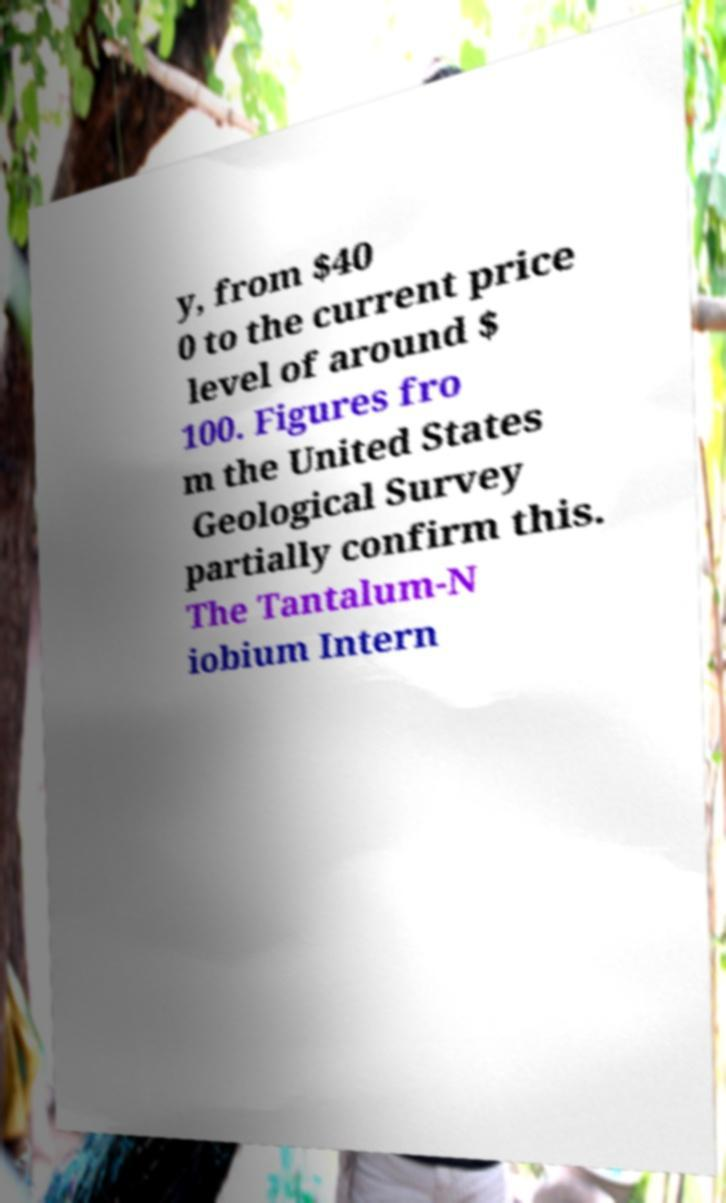What messages or text are displayed in this image? I need them in a readable, typed format. y, from $40 0 to the current price level of around $ 100. Figures fro m the United States Geological Survey partially confirm this. The Tantalum-N iobium Intern 